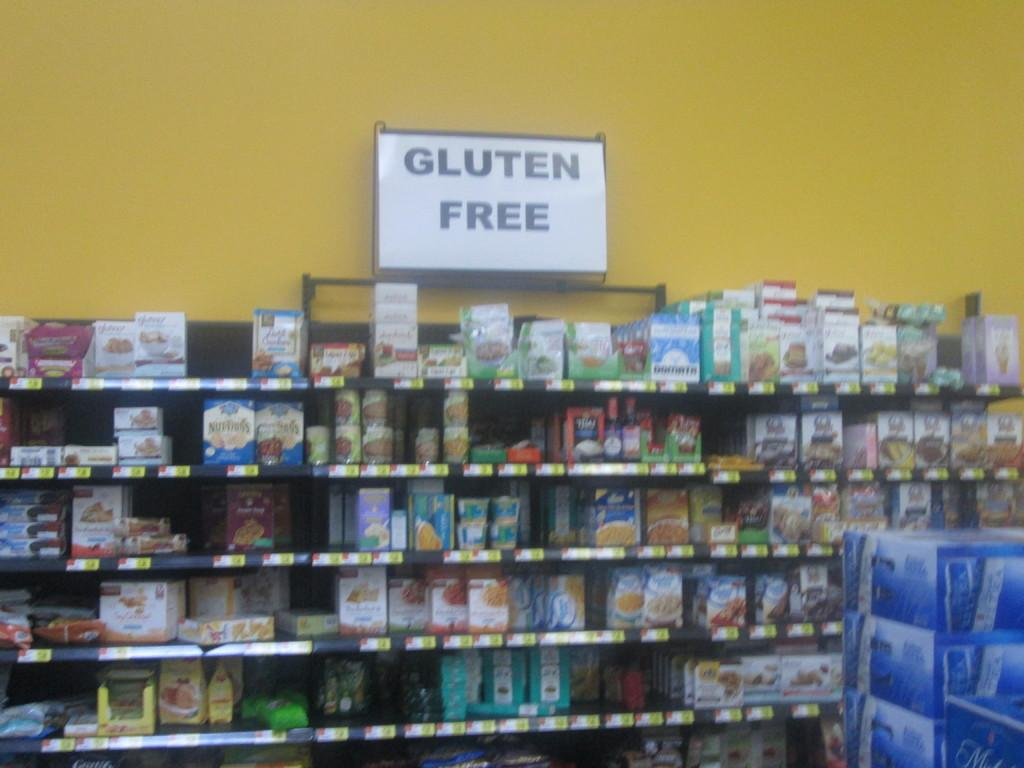<image>
Render a clear and concise summary of the photo. In a store there is a sign on the wall claiming products are gluten free. 